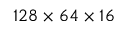<formula> <loc_0><loc_0><loc_500><loc_500>1 2 8 \times 6 4 \times 1 6</formula> 